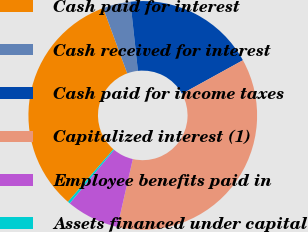Convert chart to OTSL. <chart><loc_0><loc_0><loc_500><loc_500><pie_chart><fcel>Cash paid for interest<fcel>Cash received for interest<fcel>Cash paid for income taxes<fcel>Capitalized interest (1)<fcel>Employee benefits paid in<fcel>Assets financed under capital<nl><fcel>33.02%<fcel>3.9%<fcel>18.72%<fcel>36.58%<fcel>7.46%<fcel>0.33%<nl></chart> 